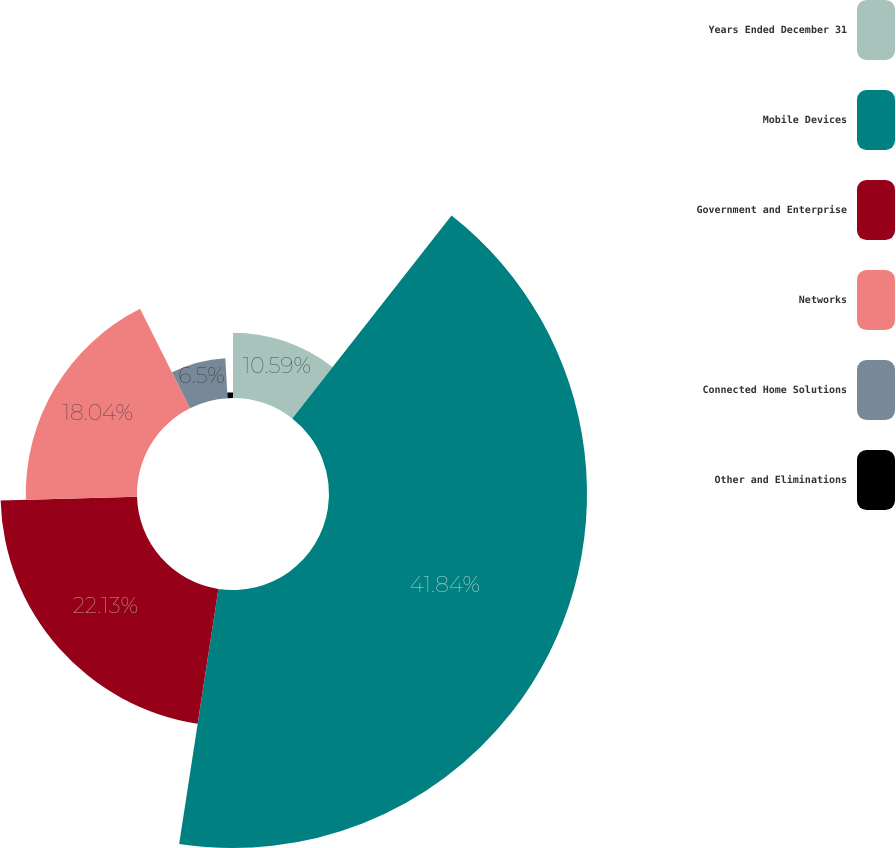Convert chart. <chart><loc_0><loc_0><loc_500><loc_500><pie_chart><fcel>Years Ended December 31<fcel>Mobile Devices<fcel>Government and Enterprise<fcel>Networks<fcel>Connected Home Solutions<fcel>Other and Eliminations<nl><fcel>10.59%<fcel>41.84%<fcel>22.13%<fcel>18.04%<fcel>6.5%<fcel>0.9%<nl></chart> 